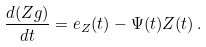<formula> <loc_0><loc_0><loc_500><loc_500>\frac { d ( Z g ) } { d t } = e _ { Z } ( t ) - \Psi ( t ) Z ( t ) \, .</formula> 